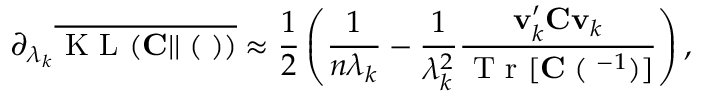Convert formula to latex. <formula><loc_0><loc_0><loc_500><loc_500>\partial _ { \lambda _ { k } } \overline { { K L ( { C } | | { \Xi } ( { \Lambda } ) ) } } \approx \frac { 1 } { 2 } \left ( \frac { 1 } { n \lambda _ { k } } - \frac { 1 } { \lambda _ { k } ^ { 2 } } \frac { { v } _ { k } ^ { \prime } { C } { v } _ { k } } { T r [ { C \Xi } ( { \Lambda } ^ { - 1 } ) ] } \right ) ,</formula> 